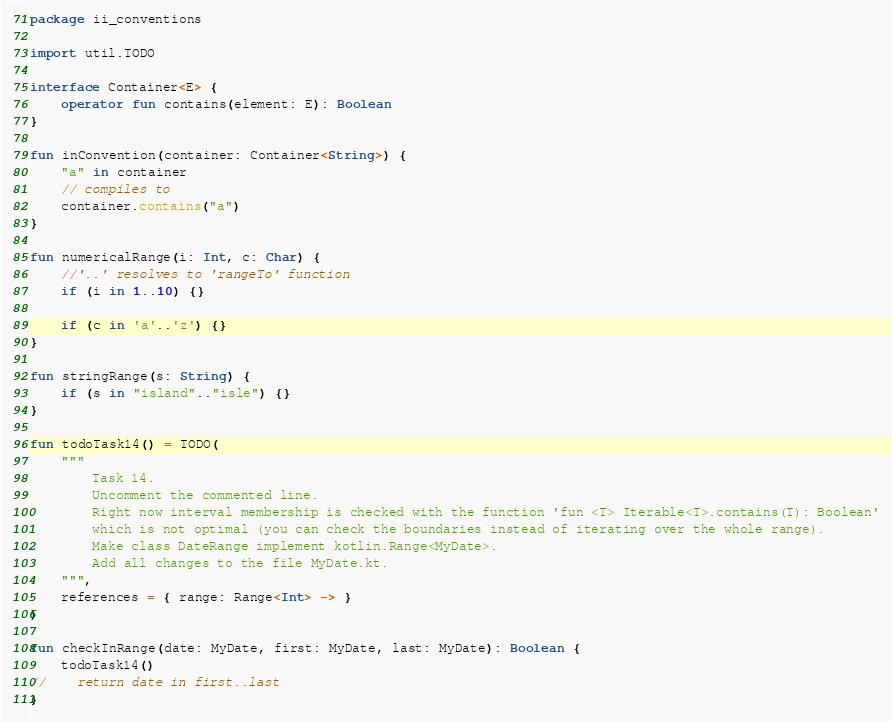<code> <loc_0><loc_0><loc_500><loc_500><_Kotlin_>package ii_conventions

import util.TODO

interface Container<E> {
    operator fun contains(element: E): Boolean
}

fun inConvention(container: Container<String>) {
    "a" in container
    // compiles to
    container.contains("a")
}

fun numericalRange(i: Int, c: Char) {
    //'..' resolves to 'rangeTo' function
    if (i in 1..10) {}

    if (c in 'a'..'z') {}
}

fun stringRange(s: String) {
    if (s in "island".."isle") {}
}

fun todoTask14() = TODO(
    """
        Task 14.
        Uncomment the commented line.
        Right now interval membership is checked with the function 'fun <T> Iterable<T>.contains(T): Boolean'
        which is not optimal (you can check the boundaries instead of iterating over the whole range).
        Make class DateRange implement kotlin.Range<MyDate>.
        Add all changes to the file MyDate.kt.
    """,
    references = { range: Range<Int> -> }
)

fun checkInRange(date: MyDate, first: MyDate, last: MyDate): Boolean {
    todoTask14()
//    return date in first..last
}
</code> 